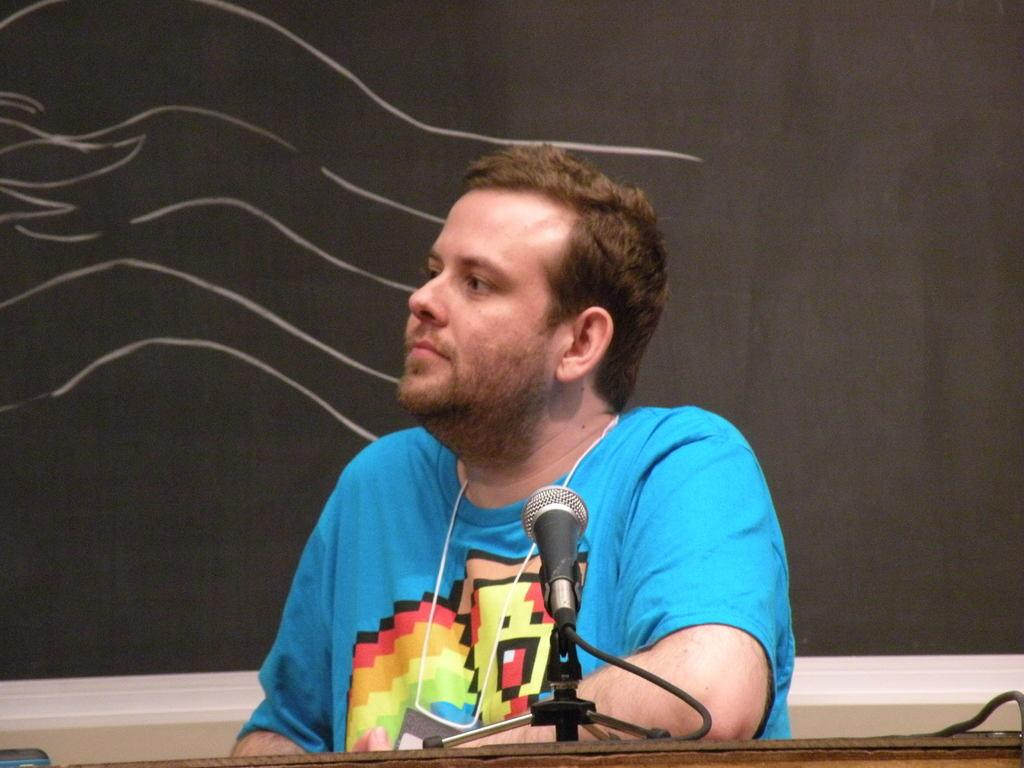What is the man in the image doing? The man is sitting in the image. What is the man wearing? The man is wearing a blue t-shirt. What object can be seen in the image that is typically used for amplifying sound? There is a microphone in the image. What type of pet is sitting on the tray in the image? There is no tray or pet present in the image. How many rings is the man wearing on his left hand in the image? The man is not wearing any rings in the image. 